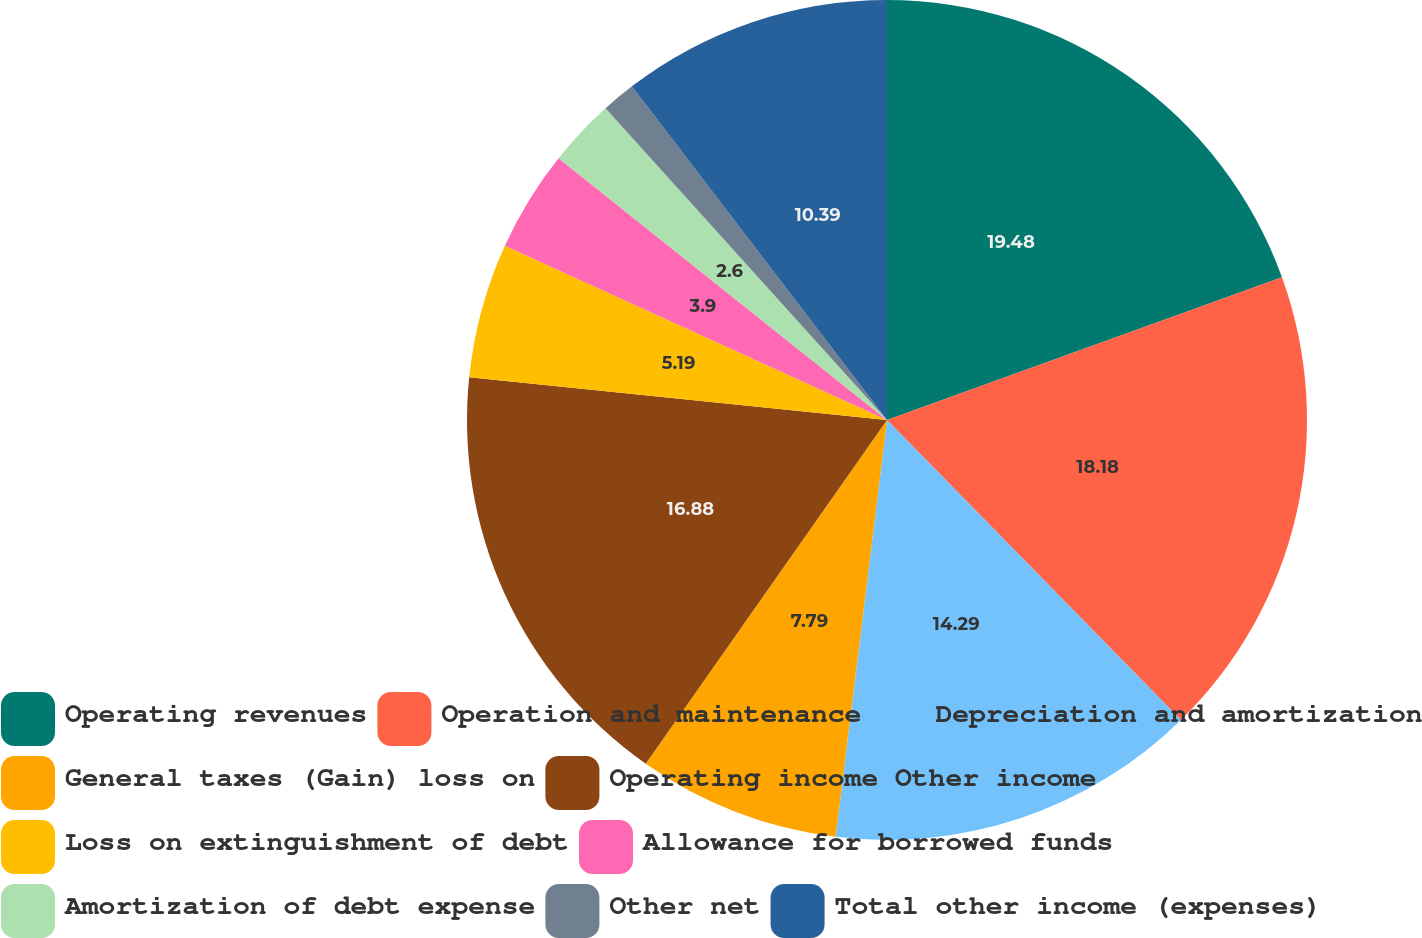Convert chart. <chart><loc_0><loc_0><loc_500><loc_500><pie_chart><fcel>Operating revenues<fcel>Operation and maintenance<fcel>Depreciation and amortization<fcel>General taxes (Gain) loss on<fcel>Operating income Other income<fcel>Loss on extinguishment of debt<fcel>Allowance for borrowed funds<fcel>Amortization of debt expense<fcel>Other net<fcel>Total other income (expenses)<nl><fcel>19.48%<fcel>18.18%<fcel>14.29%<fcel>7.79%<fcel>16.88%<fcel>5.19%<fcel>3.9%<fcel>2.6%<fcel>1.3%<fcel>10.39%<nl></chart> 